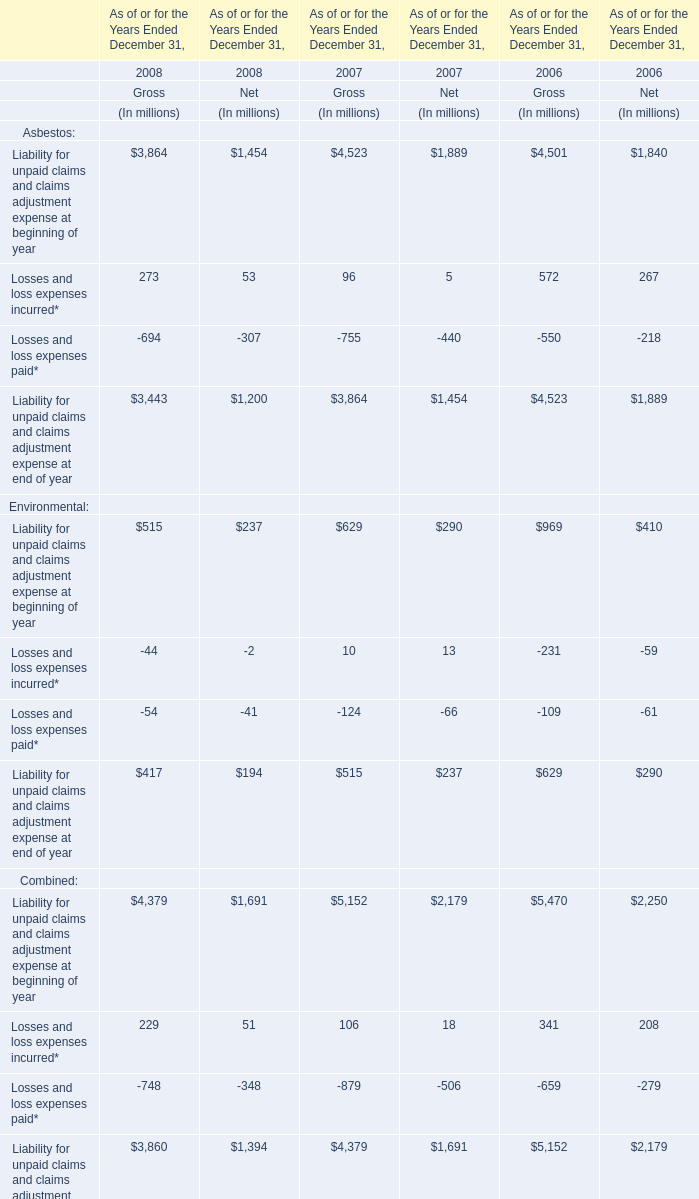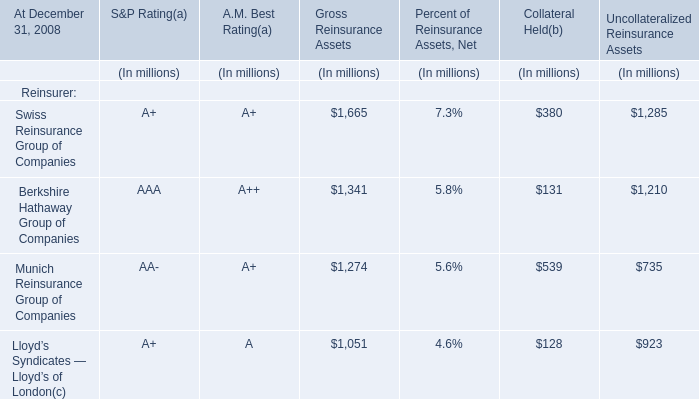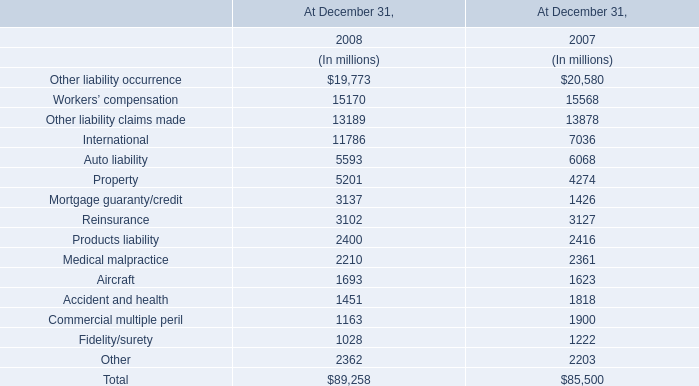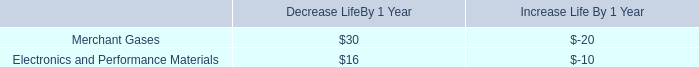What is the ratioof Losses and loss expenses incurred of Gross to the total in 2008? 
Computations: (273 / (273 + 53))
Answer: 0.83742. 